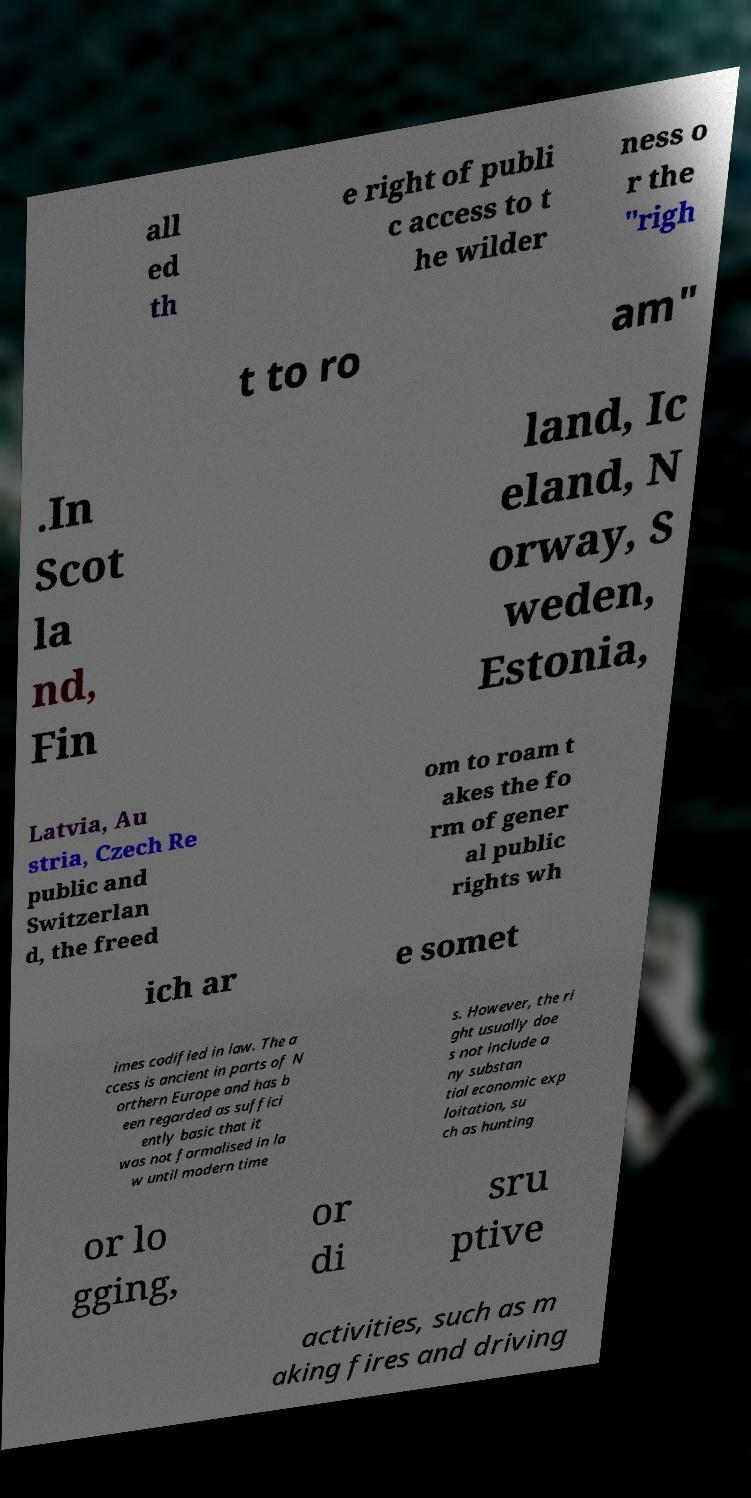Could you assist in decoding the text presented in this image and type it out clearly? all ed th e right of publi c access to t he wilder ness o r the "righ t to ro am" .In Scot la nd, Fin land, Ic eland, N orway, S weden, Estonia, Latvia, Au stria, Czech Re public and Switzerlan d, the freed om to roam t akes the fo rm of gener al public rights wh ich ar e somet imes codified in law. The a ccess is ancient in parts of N orthern Europe and has b een regarded as suffici ently basic that it was not formalised in la w until modern time s. However, the ri ght usually doe s not include a ny substan tial economic exp loitation, su ch as hunting or lo gging, or di sru ptive activities, such as m aking fires and driving 